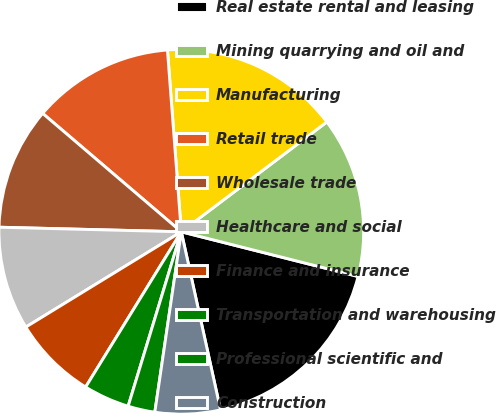Convert chart. <chart><loc_0><loc_0><loc_500><loc_500><pie_chart><fcel>Real estate rental and leasing<fcel>Mining quarrying and oil and<fcel>Manufacturing<fcel>Retail trade<fcel>Wholesale trade<fcel>Healthcare and social<fcel>Finance and insurance<fcel>Transportation and warehousing<fcel>Professional scientific and<fcel>Construction<nl><fcel>17.61%<fcel>14.23%<fcel>15.92%<fcel>12.54%<fcel>10.85%<fcel>9.15%<fcel>7.46%<fcel>4.08%<fcel>2.39%<fcel>5.77%<nl></chart> 